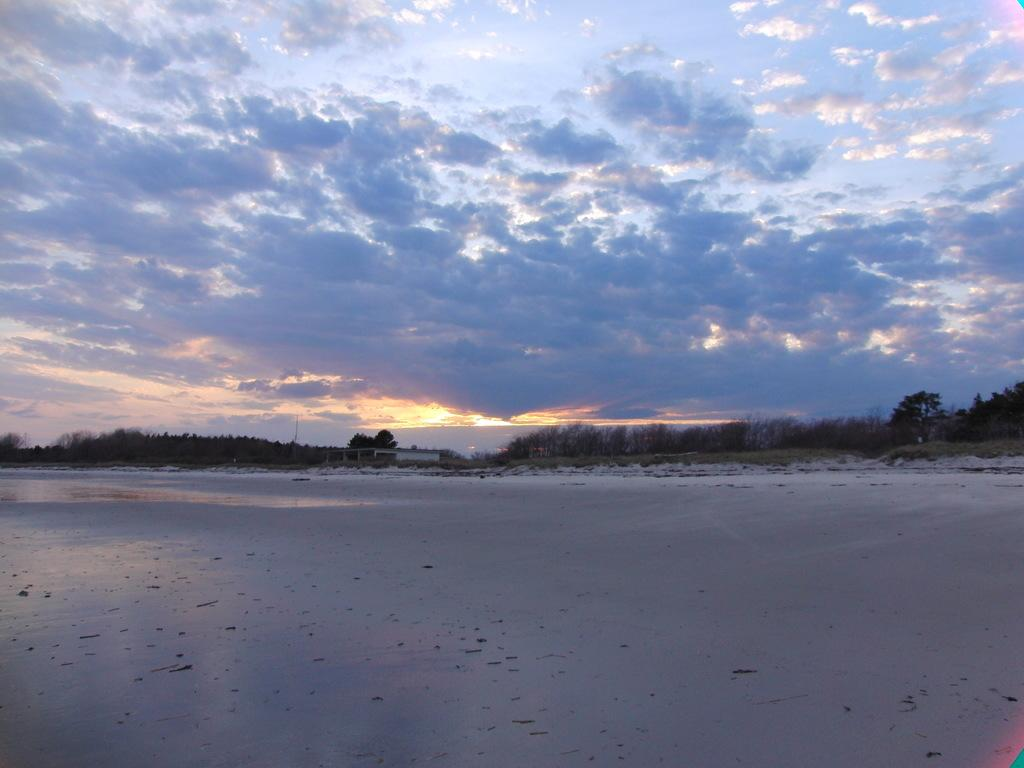What type of vegetation can be seen in the image? There are trees in the image. What type of terrain is visible in the image? There is sand in the image. What is visible in the background of the image? The sky is visible in the image. How many screws can be seen in the image? There are no screws present in the image. 